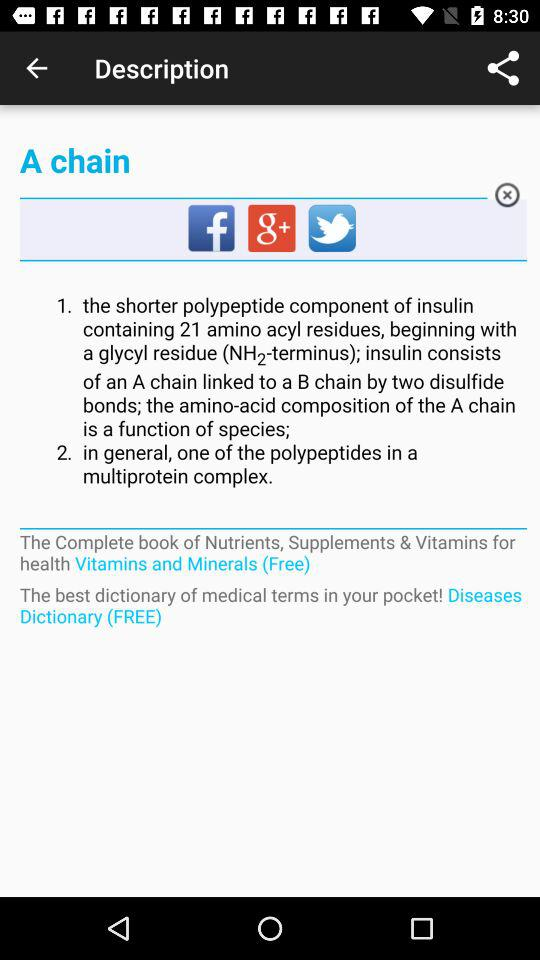What are the available social media options? The available social media options are "Facebook", "Google+" and "Twitter". 